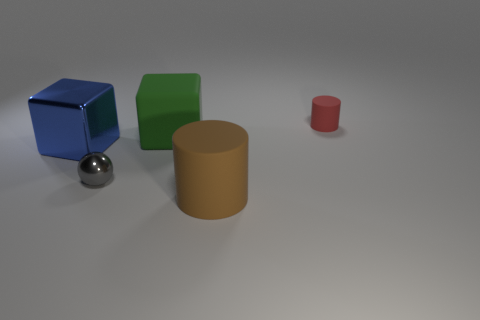Add 1 brown shiny balls. How many objects exist? 6 Subtract all cylinders. How many objects are left? 3 Subtract all green cylinders. Subtract all purple balls. How many cylinders are left? 2 Subtract all rubber cylinders. Subtract all tiny red rubber cylinders. How many objects are left? 2 Add 1 red objects. How many red objects are left? 2 Add 1 tiny green spheres. How many tiny green spheres exist? 1 Subtract 0 green cylinders. How many objects are left? 5 